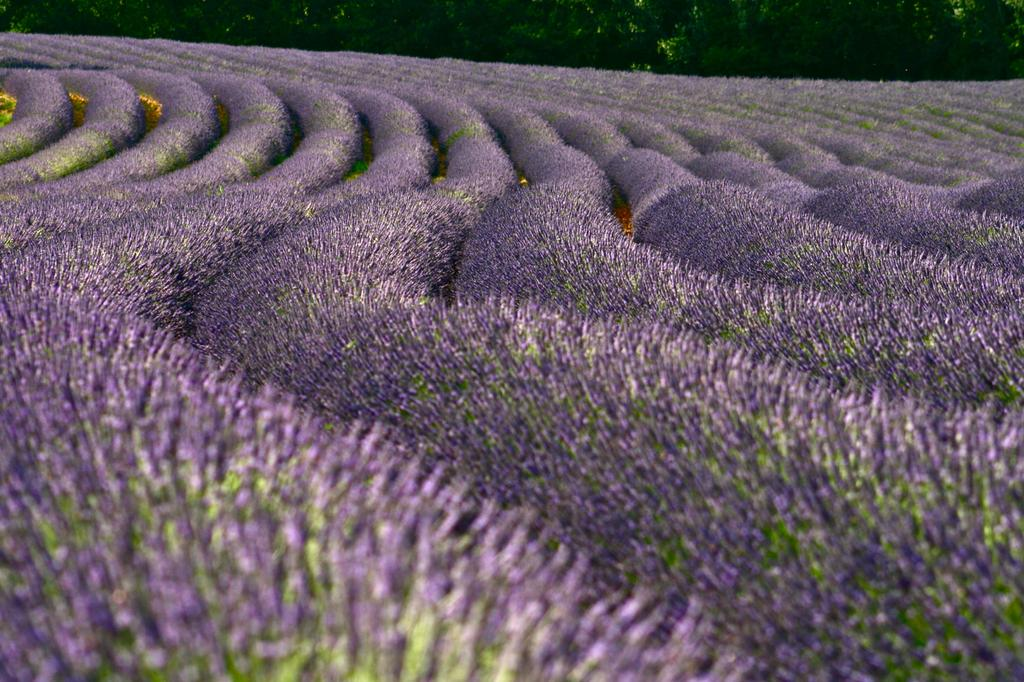What type of vegetation can be seen in the image? There are flower beds in the image. What can be seen in the background of the image? There are trees in the background of the image. How much money does the government allocate for the maintenance of the flower beds in the image? There is no information about the government or the allocation of funds in the image, so it cannot be determined. 